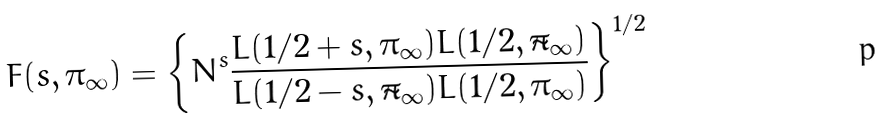Convert formula to latex. <formula><loc_0><loc_0><loc_500><loc_500>F ( s , \pi _ { \infty } ) = \left \{ N ^ { s } \frac { L ( 1 / 2 + s , \pi _ { \infty } ) L ( 1 / 2 , \tilde { \pi } _ { \infty } ) } { L ( 1 / 2 - s , \tilde { \pi } _ { \infty } ) L ( 1 / 2 , \pi _ { \infty } ) } \right \} ^ { 1 / 2 }</formula> 